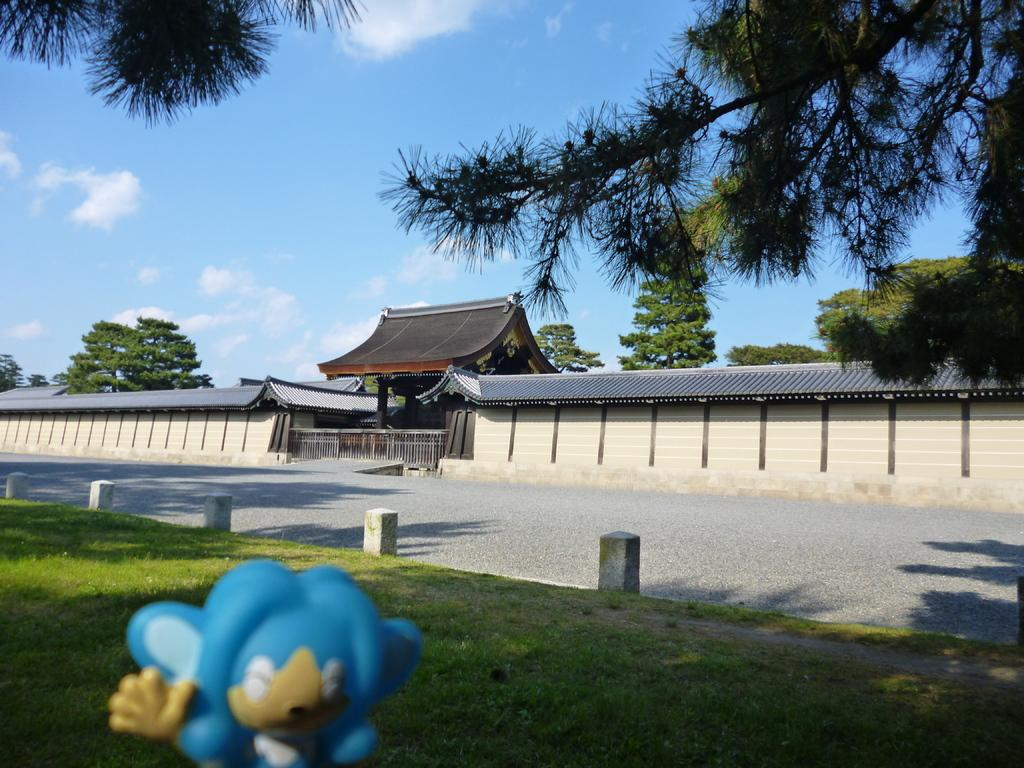What type of vegetation is present in the image? There is grass in the image. What can be seen in the foreground of the image? There is a blue color object in the foreground. What type of man-made structure is visible in the image? There is a road, a building, and a wall in the image. What other natural elements are present in the image? There are trees and clouds in the image. Can you see any fish swimming in the grass in the image? There are no fish present in the image, as it features grass and other elements. 